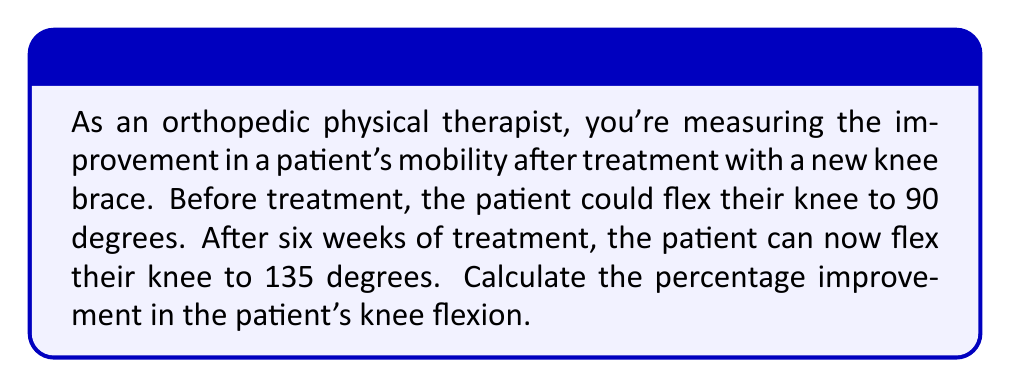Give your solution to this math problem. To calculate the percentage improvement, we need to follow these steps:

1. Calculate the change in knee flexion:
   $\text{Change} = \text{Final flexion} - \text{Initial flexion}$
   $\text{Change} = 135^\circ - 90^\circ = 45^\circ$

2. Calculate the percentage improvement using the formula:
   $$\text{Percentage improvement} = \frac{\text{Change}}{\text{Initial value}} \times 100\%$$

3. Substitute the values into the formula:
   $$\text{Percentage improvement} = \frac{45^\circ}{90^\circ} \times 100\%$$

4. Perform the division:
   $$\text{Percentage improvement} = 0.5 \times 100\%$$

5. Convert the decimal to a percentage:
   $$\text{Percentage improvement} = 50\%$$

Therefore, the patient's knee flexion has improved by 50% after six weeks of treatment with the new knee brace.
Answer: 50% 